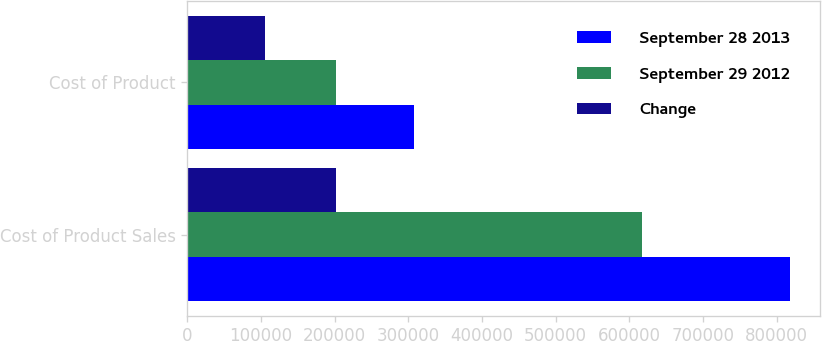Convert chart. <chart><loc_0><loc_0><loc_500><loc_500><stacked_bar_chart><ecel><fcel>Cost of Product Sales<fcel>Cost of Product<nl><fcel>September 28 2013<fcel>818160<fcel>307895<nl><fcel>September 29 2012<fcel>616839<fcel>201864<nl><fcel>Change<fcel>201321<fcel>106031<nl></chart> 